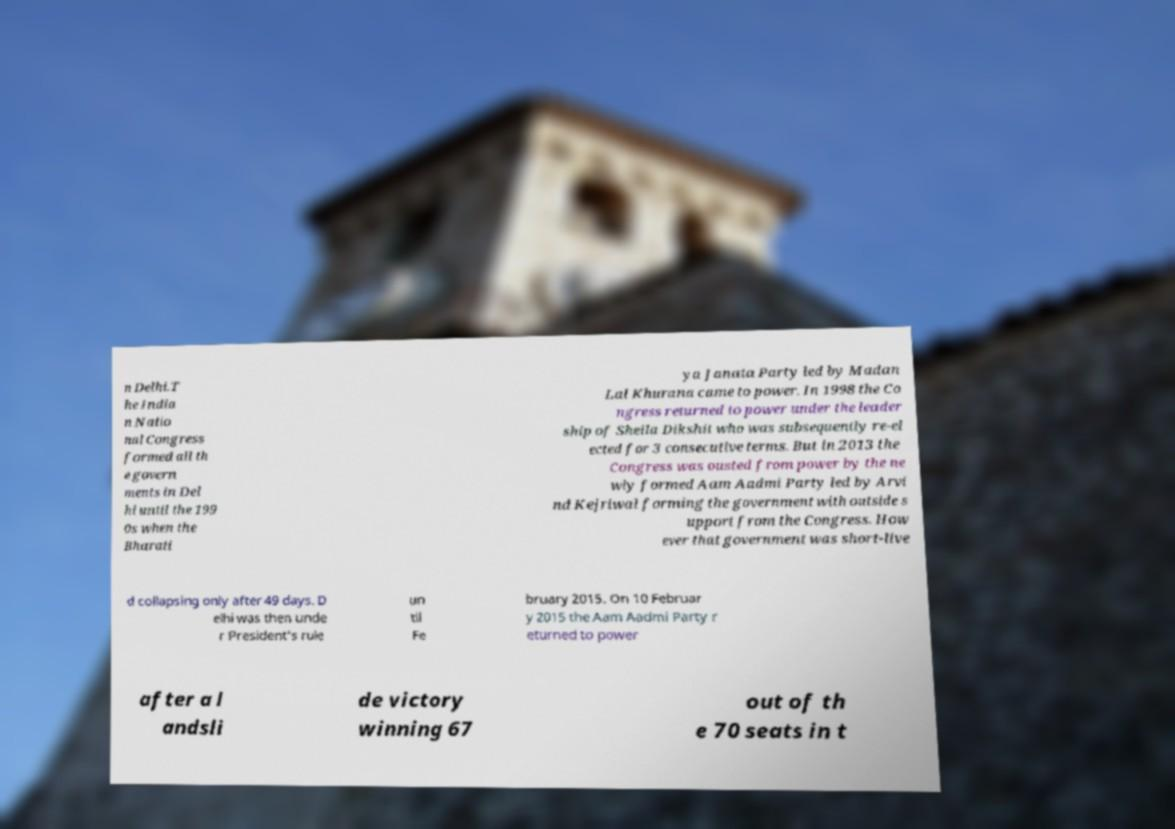Can you accurately transcribe the text from the provided image for me? n Delhi.T he India n Natio nal Congress formed all th e govern ments in Del hi until the 199 0s when the Bharati ya Janata Party led by Madan Lal Khurana came to power. In 1998 the Co ngress returned to power under the leader ship of Sheila Dikshit who was subsequently re-el ected for 3 consecutive terms. But in 2013 the Congress was ousted from power by the ne wly formed Aam Aadmi Party led by Arvi nd Kejriwal forming the government with outside s upport from the Congress. How ever that government was short-live d collapsing only after 49 days. D elhi was then unde r President's rule un til Fe bruary 2015. On 10 Februar y 2015 the Aam Aadmi Party r eturned to power after a l andsli de victory winning 67 out of th e 70 seats in t 